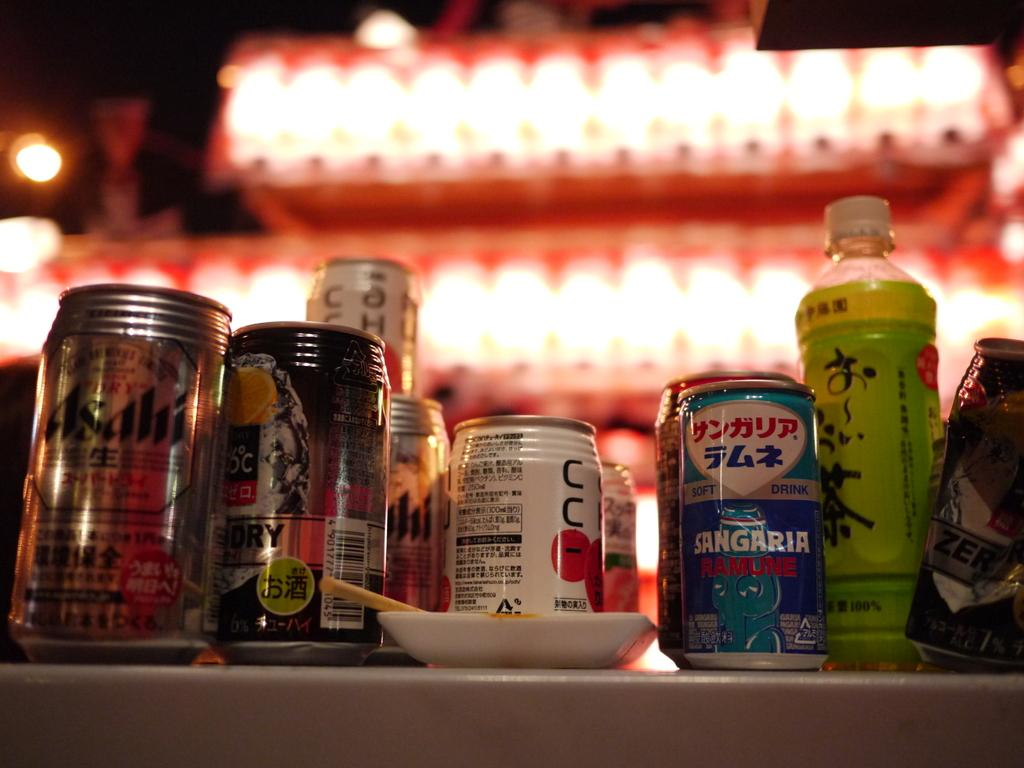<image>
Present a compact description of the photo's key features. A variation of japanese cans with one being sangaria ramune 